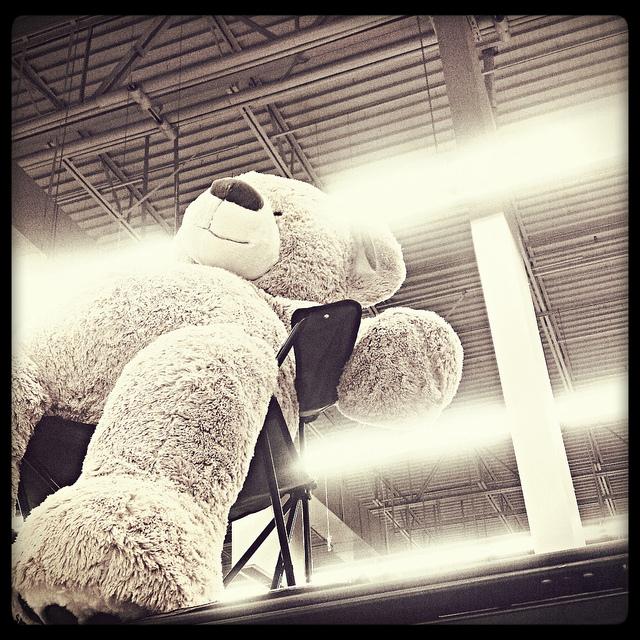What color is the picture?
Concise answer only. Black and white. Where is light coming from?
Answer briefly. Ceiling. Is the bear in a fold-up chair?
Concise answer only. Yes. What is sitting in the chair?
Be succinct. Teddy bear. 